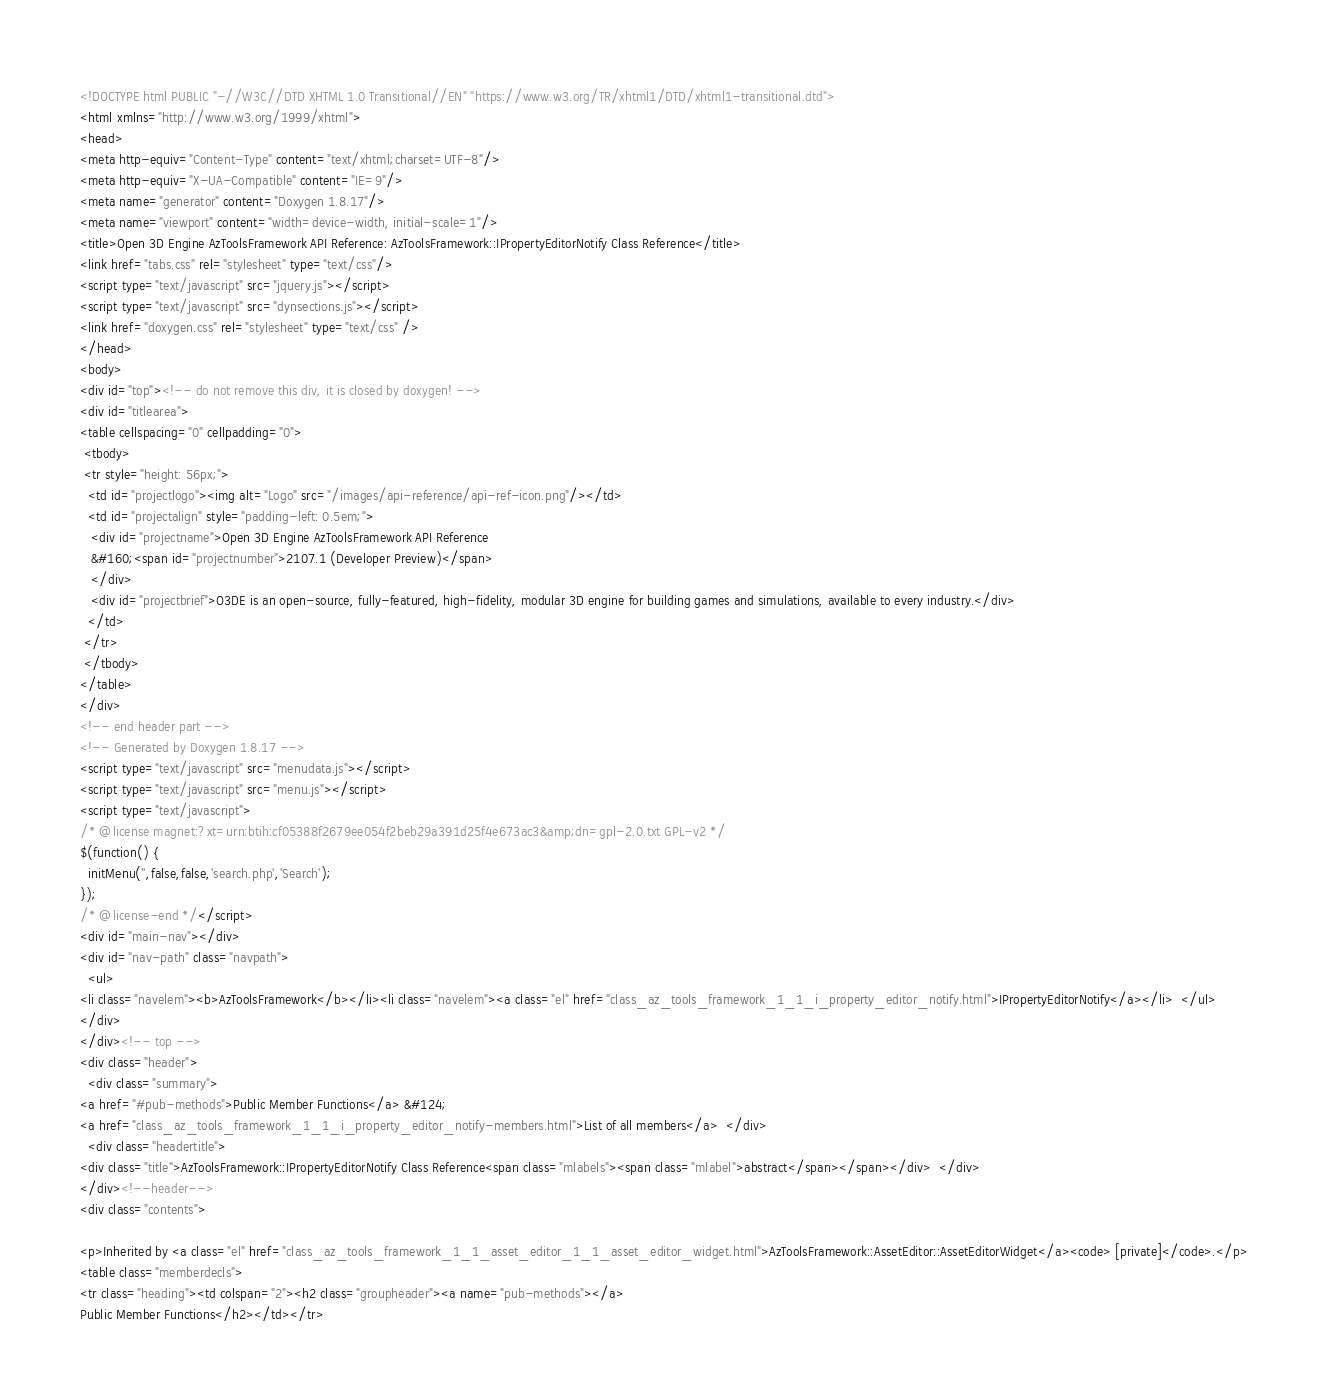Convert code to text. <code><loc_0><loc_0><loc_500><loc_500><_HTML_><!DOCTYPE html PUBLIC "-//W3C//DTD XHTML 1.0 Transitional//EN" "https://www.w3.org/TR/xhtml1/DTD/xhtml1-transitional.dtd">
<html xmlns="http://www.w3.org/1999/xhtml">
<head>
<meta http-equiv="Content-Type" content="text/xhtml;charset=UTF-8"/>
<meta http-equiv="X-UA-Compatible" content="IE=9"/>
<meta name="generator" content="Doxygen 1.8.17"/>
<meta name="viewport" content="width=device-width, initial-scale=1"/>
<title>Open 3D Engine AzToolsFramework API Reference: AzToolsFramework::IPropertyEditorNotify Class Reference</title>
<link href="tabs.css" rel="stylesheet" type="text/css"/>
<script type="text/javascript" src="jquery.js"></script>
<script type="text/javascript" src="dynsections.js"></script>
<link href="doxygen.css" rel="stylesheet" type="text/css" />
</head>
<body>
<div id="top"><!-- do not remove this div, it is closed by doxygen! -->
<div id="titlearea">
<table cellspacing="0" cellpadding="0">
 <tbody>
 <tr style="height: 56px;">
  <td id="projectlogo"><img alt="Logo" src="/images/api-reference/api-ref-icon.png"/></td>
  <td id="projectalign" style="padding-left: 0.5em;">
   <div id="projectname">Open 3D Engine AzToolsFramework API Reference
   &#160;<span id="projectnumber">2107.1 (Developer Preview)</span>
   </div>
   <div id="projectbrief">O3DE is an open-source, fully-featured, high-fidelity, modular 3D engine for building games and simulations, available to every industry.</div>
  </td>
 </tr>
 </tbody>
</table>
</div>
<!-- end header part -->
<!-- Generated by Doxygen 1.8.17 -->
<script type="text/javascript" src="menudata.js"></script>
<script type="text/javascript" src="menu.js"></script>
<script type="text/javascript">
/* @license magnet:?xt=urn:btih:cf05388f2679ee054f2beb29a391d25f4e673ac3&amp;dn=gpl-2.0.txt GPL-v2 */
$(function() {
  initMenu('',false,false,'search.php','Search');
});
/* @license-end */</script>
<div id="main-nav"></div>
<div id="nav-path" class="navpath">
  <ul>
<li class="navelem"><b>AzToolsFramework</b></li><li class="navelem"><a class="el" href="class_az_tools_framework_1_1_i_property_editor_notify.html">IPropertyEditorNotify</a></li>  </ul>
</div>
</div><!-- top -->
<div class="header">
  <div class="summary">
<a href="#pub-methods">Public Member Functions</a> &#124;
<a href="class_az_tools_framework_1_1_i_property_editor_notify-members.html">List of all members</a>  </div>
  <div class="headertitle">
<div class="title">AzToolsFramework::IPropertyEditorNotify Class Reference<span class="mlabels"><span class="mlabel">abstract</span></span></div>  </div>
</div><!--header-->
<div class="contents">

<p>Inherited by <a class="el" href="class_az_tools_framework_1_1_asset_editor_1_1_asset_editor_widget.html">AzToolsFramework::AssetEditor::AssetEditorWidget</a><code> [private]</code>.</p>
<table class="memberdecls">
<tr class="heading"><td colspan="2"><h2 class="groupheader"><a name="pub-methods"></a>
Public Member Functions</h2></td></tr></code> 